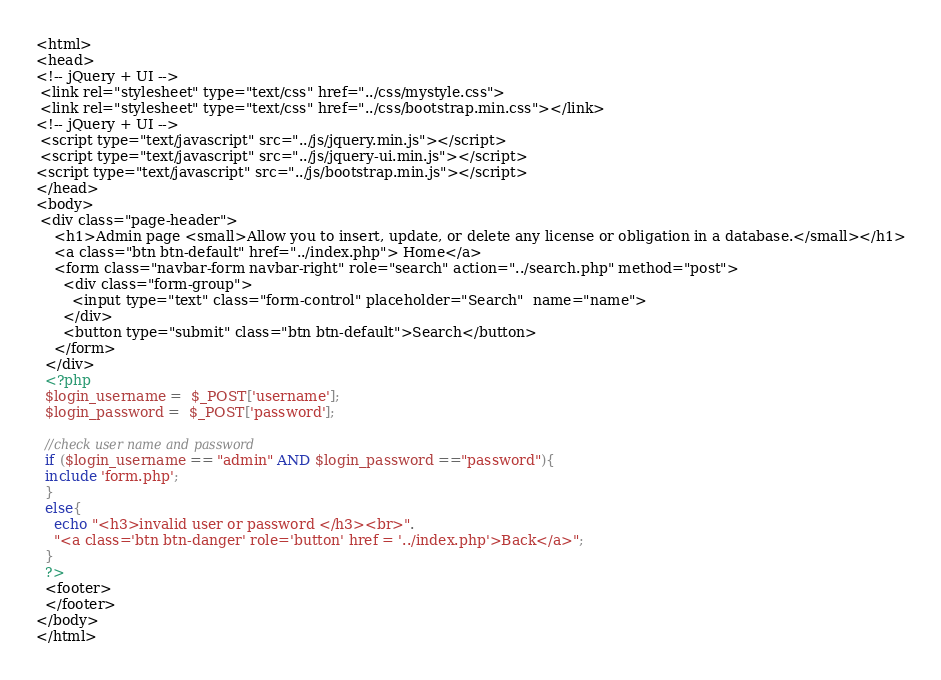Convert code to text. <code><loc_0><loc_0><loc_500><loc_500><_PHP_><html>
<head>
<!-- jQuery + UI -->
 <link rel="stylesheet" type="text/css" href="../css/mystyle.css">
 <link rel="stylesheet" type="text/css" href="../css/bootstrap.min.css"></link>
<!-- jQuery + UI -->
 <script type="text/javascript" src="../js/jquery.min.js"></script>
 <script type="text/javascript" src="../js/jquery-ui.min.js"></script>
<script type="text/javascript" src="../js/bootstrap.min.js"></script> 
</head>
<body>
 <div class="page-header">
    <h1>Admin page <small>Allow you to insert, update, or delete any license or obligation in a database.</small></h1>
    <a class="btn btn-default" href="../index.php"> Home</a>
    <form class="navbar-form navbar-right" role="search" action="../search.php" method="post">
      <div class="form-group">
        <input type="text" class="form-control" placeholder="Search"  name="name">
      </div>
      <button type="submit" class="btn btn-default">Search</button>
    </form>
  </div>
  <?php
  $login_username =  $_POST['username'];
  $login_password =  $_POST['password'];

  //check user name and password
  if ($login_username == "admin" AND $login_password =="password"){
  include 'form.php';
  }
  else{
    echo "<h3>invalid user or password </h3><br>".
    "<a class='btn btn-danger' role='button' href = '../index.php'>Back</a>";
  }
  ?>
  <footer>
  </footer>
</body>
</html>
</code> 